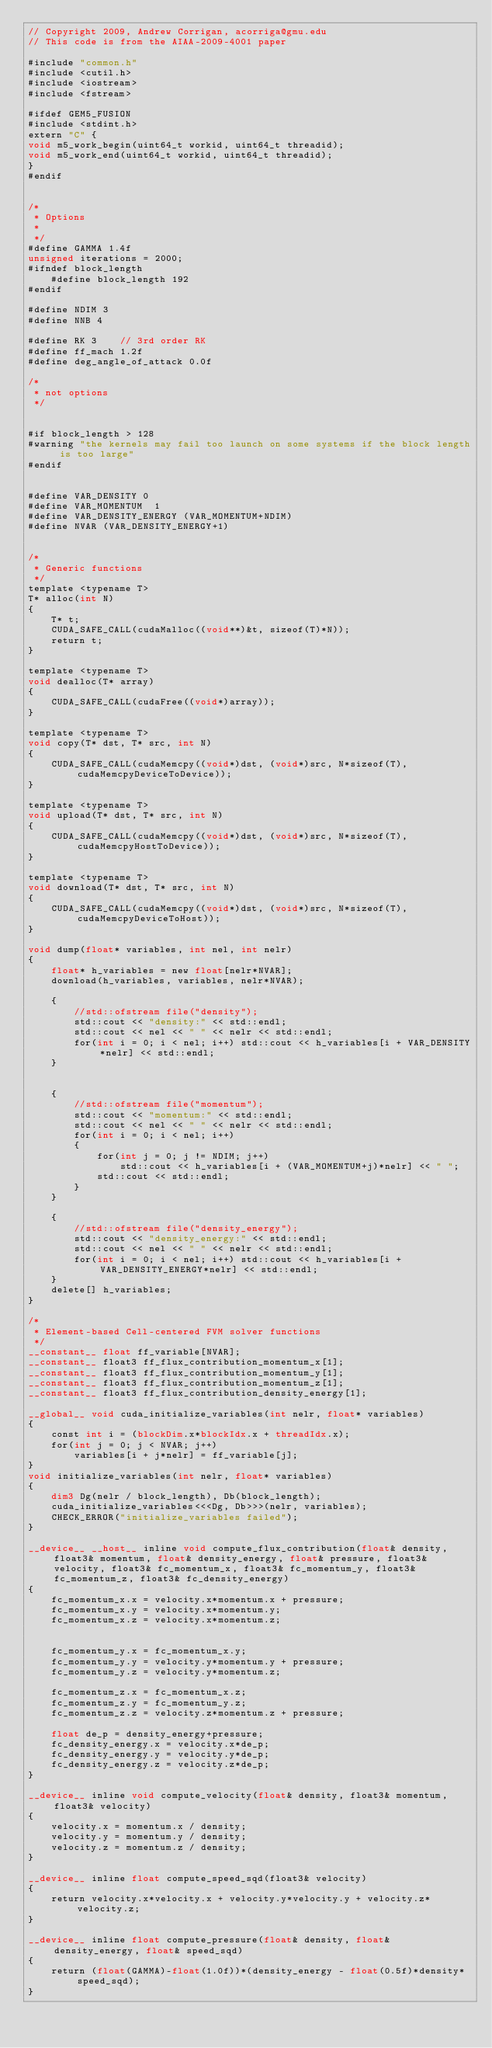<code> <loc_0><loc_0><loc_500><loc_500><_Cuda_>// Copyright 2009, Andrew Corrigan, acorriga@gmu.edu
// This code is from the AIAA-2009-4001 paper

#include "common.h"
#include <cutil.h>
#include <iostream>
#include <fstream>

#ifdef GEM5_FUSION
#include <stdint.h>
extern "C" {
void m5_work_begin(uint64_t workid, uint64_t threadid);
void m5_work_end(uint64_t workid, uint64_t threadid);
}
#endif
 
 
/*
 * Options 
 * 
 */ 
#define GAMMA 1.4f
unsigned iterations = 2000;
#ifndef block_length
	#define block_length 192
#endif

#define NDIM 3
#define NNB 4

#define RK 3	// 3rd order RK
#define ff_mach 1.2f
#define deg_angle_of_attack 0.0f

/*
 * not options
 */


#if block_length > 128
#warning "the kernels may fail too launch on some systems if the block length is too large"
#endif


#define VAR_DENSITY 0
#define VAR_MOMENTUM  1
#define VAR_DENSITY_ENERGY (VAR_MOMENTUM+NDIM)
#define NVAR (VAR_DENSITY_ENERGY+1)


/*
 * Generic functions
 */
template <typename T>
T* alloc(int N)
{
	T* t;
	CUDA_SAFE_CALL(cudaMalloc((void**)&t, sizeof(T)*N));
	return t;
}

template <typename T>
void dealloc(T* array)
{
	CUDA_SAFE_CALL(cudaFree((void*)array));
}

template <typename T>
void copy(T* dst, T* src, int N)
{
	CUDA_SAFE_CALL(cudaMemcpy((void*)dst, (void*)src, N*sizeof(T), cudaMemcpyDeviceToDevice));
}

template <typename T>
void upload(T* dst, T* src, int N)
{
	CUDA_SAFE_CALL(cudaMemcpy((void*)dst, (void*)src, N*sizeof(T), cudaMemcpyHostToDevice));
}

template <typename T>
void download(T* dst, T* src, int N)
{
	CUDA_SAFE_CALL(cudaMemcpy((void*)dst, (void*)src, N*sizeof(T), cudaMemcpyDeviceToHost));
}

void dump(float* variables, int nel, int nelr)
{
	float* h_variables = new float[nelr*NVAR];
	download(h_variables, variables, nelr*NVAR);

	{
		//std::ofstream file("density");
		std::cout << "density:" << std::endl;
		std::cout << nel << " " << nelr << std::endl;
		for(int i = 0; i < nel; i++) std::cout << h_variables[i + VAR_DENSITY*nelr] << std::endl;
	}


	{
		//std::ofstream file("momentum");
		std::cout << "momentum:" << std::endl;
		std::cout << nel << " " << nelr << std::endl;
		for(int i = 0; i < nel; i++)
		{
			for(int j = 0; j != NDIM; j++)
				std::cout << h_variables[i + (VAR_MOMENTUM+j)*nelr] << " ";
			std::cout << std::endl;
		}
	}
	
	{
		//std::ofstream file("density_energy");
		std::cout << "density_energy:" << std::endl;
		std::cout << nel << " " << nelr << std::endl;
		for(int i = 0; i < nel; i++) std::cout << h_variables[i + VAR_DENSITY_ENERGY*nelr] << std::endl;
	}
	delete[] h_variables;
}

/*
 * Element-based Cell-centered FVM solver functions
 */
__constant__ float ff_variable[NVAR];
__constant__ float3 ff_flux_contribution_momentum_x[1];
__constant__ float3 ff_flux_contribution_momentum_y[1];
__constant__ float3 ff_flux_contribution_momentum_z[1];
__constant__ float3 ff_flux_contribution_density_energy[1];

__global__ void cuda_initialize_variables(int nelr, float* variables)
{
	const int i = (blockDim.x*blockIdx.x + threadIdx.x);
	for(int j = 0; j < NVAR; j++)
		variables[i + j*nelr] = ff_variable[j];
}
void initialize_variables(int nelr, float* variables)
{
	dim3 Dg(nelr / block_length), Db(block_length);
	cuda_initialize_variables<<<Dg, Db>>>(nelr, variables);
	CHECK_ERROR("initialize_variables failed");
}

__device__ __host__ inline void compute_flux_contribution(float& density, float3& momentum, float& density_energy, float& pressure, float3& velocity, float3& fc_momentum_x, float3& fc_momentum_y, float3& fc_momentum_z, float3& fc_density_energy)
{
	fc_momentum_x.x = velocity.x*momentum.x + pressure;
	fc_momentum_x.y = velocity.x*momentum.y;
	fc_momentum_x.z = velocity.x*momentum.z;
	
	
	fc_momentum_y.x = fc_momentum_x.y;
	fc_momentum_y.y = velocity.y*momentum.y + pressure;
	fc_momentum_y.z = velocity.y*momentum.z;

	fc_momentum_z.x = fc_momentum_x.z;
	fc_momentum_z.y = fc_momentum_y.z;
	fc_momentum_z.z = velocity.z*momentum.z + pressure;

	float de_p = density_energy+pressure;
	fc_density_energy.x = velocity.x*de_p;
	fc_density_energy.y = velocity.y*de_p;
	fc_density_energy.z = velocity.z*de_p;
}

__device__ inline void compute_velocity(float& density, float3& momentum, float3& velocity)
{
	velocity.x = momentum.x / density;
	velocity.y = momentum.y / density;
	velocity.z = momentum.z / density;
}
	
__device__ inline float compute_speed_sqd(float3& velocity)
{
	return velocity.x*velocity.x + velocity.y*velocity.y + velocity.z*velocity.z;
}

__device__ inline float compute_pressure(float& density, float& density_energy, float& speed_sqd)
{
	return (float(GAMMA)-float(1.0f))*(density_energy - float(0.5f)*density*speed_sqd);
}
</code> 